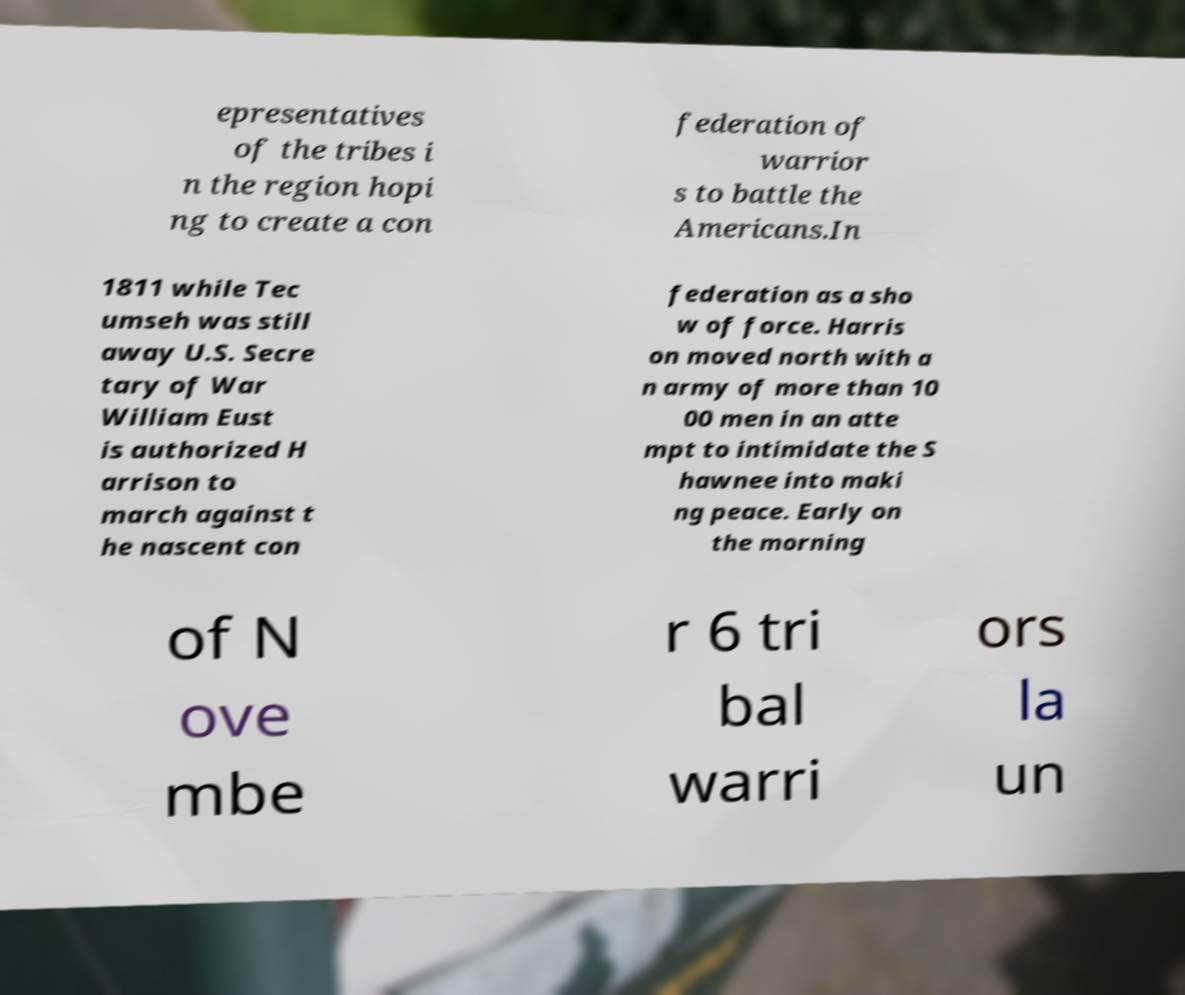Can you read and provide the text displayed in the image?This photo seems to have some interesting text. Can you extract and type it out for me? epresentatives of the tribes i n the region hopi ng to create a con federation of warrior s to battle the Americans.In 1811 while Tec umseh was still away U.S. Secre tary of War William Eust is authorized H arrison to march against t he nascent con federation as a sho w of force. Harris on moved north with a n army of more than 10 00 men in an atte mpt to intimidate the S hawnee into maki ng peace. Early on the morning of N ove mbe r 6 tri bal warri ors la un 